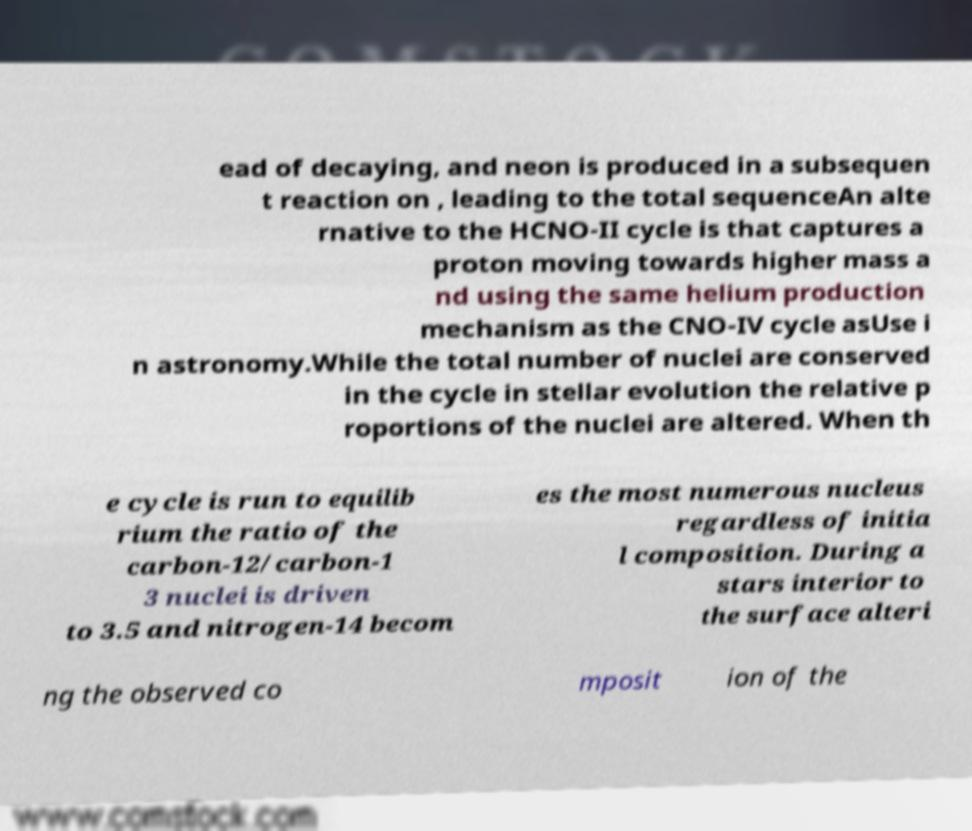I need the written content from this picture converted into text. Can you do that? ead of decaying, and neon is produced in a subsequen t reaction on , leading to the total sequenceAn alte rnative to the HCNO-II cycle is that captures a proton moving towards higher mass a nd using the same helium production mechanism as the CNO-IV cycle asUse i n astronomy.While the total number of nuclei are conserved in the cycle in stellar evolution the relative p roportions of the nuclei are altered. When th e cycle is run to equilib rium the ratio of the carbon-12/carbon-1 3 nuclei is driven to 3.5 and nitrogen-14 becom es the most numerous nucleus regardless of initia l composition. During a stars interior to the surface alteri ng the observed co mposit ion of the 